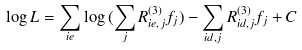<formula> <loc_0><loc_0><loc_500><loc_500>\log { L } = \sum _ { i e } \log { ( \sum _ { j } R ^ { ( 3 ) } _ { i e , j } f _ { j } ) } - \sum _ { i d , j } R ^ { ( 3 ) } _ { i d , j } f _ { j } + C</formula> 